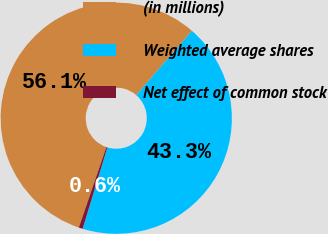Convert chart to OTSL. <chart><loc_0><loc_0><loc_500><loc_500><pie_chart><fcel>(in millions)<fcel>Weighted average shares<fcel>Net effect of common stock<nl><fcel>56.11%<fcel>43.34%<fcel>0.55%<nl></chart> 